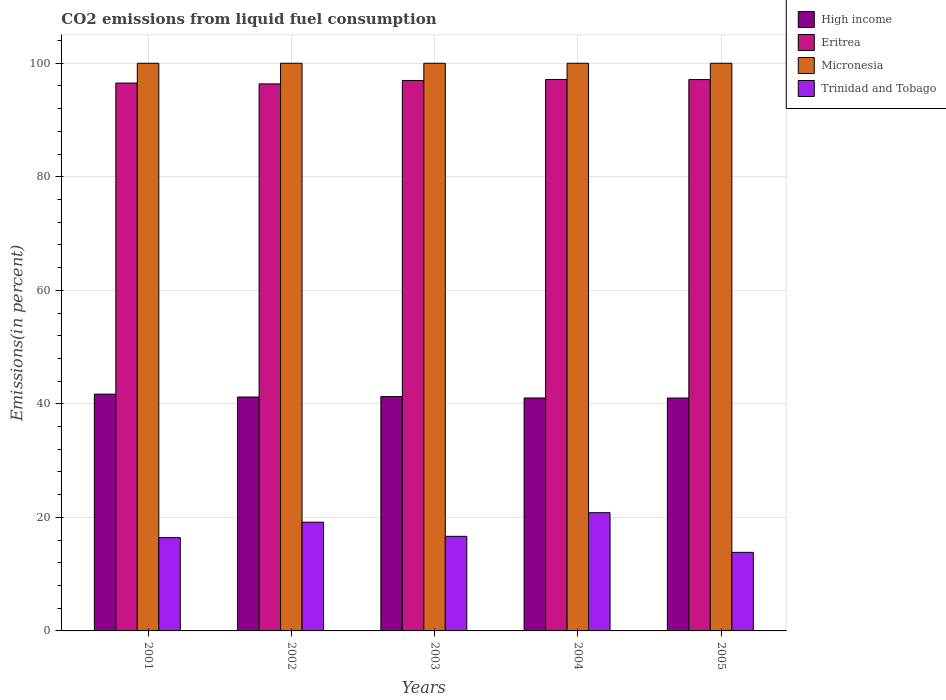How many different coloured bars are there?
Provide a succinct answer. 4. Are the number of bars on each tick of the X-axis equal?
Your answer should be very brief. Yes. How many bars are there on the 3rd tick from the left?
Keep it short and to the point. 4. How many bars are there on the 2nd tick from the right?
Your response must be concise. 4. In how many cases, is the number of bars for a given year not equal to the number of legend labels?
Your answer should be compact. 0. What is the total CO2 emitted in High income in 2001?
Provide a succinct answer. 41.71. Across all years, what is the maximum total CO2 emitted in Eritrea?
Offer a very short reply. 97.14. In which year was the total CO2 emitted in High income minimum?
Provide a short and direct response. 2005. What is the total total CO2 emitted in High income in the graph?
Your answer should be compact. 206.25. What is the difference between the total CO2 emitted in Micronesia in 2001 and that in 2004?
Make the answer very short. 0. What is the difference between the total CO2 emitted in High income in 2003 and the total CO2 emitted in Trinidad and Tobago in 2005?
Your response must be concise. 27.44. What is the average total CO2 emitted in Trinidad and Tobago per year?
Keep it short and to the point. 17.38. In the year 2001, what is the difference between the total CO2 emitted in Eritrea and total CO2 emitted in High income?
Offer a terse response. 54.8. In how many years, is the total CO2 emitted in Trinidad and Tobago greater than 16 %?
Keep it short and to the point. 4. What is the ratio of the total CO2 emitted in Trinidad and Tobago in 2001 to that in 2003?
Make the answer very short. 0.99. Is the total CO2 emitted in Micronesia in 2003 less than that in 2004?
Your response must be concise. No. What is the difference between the highest and the second highest total CO2 emitted in Trinidad and Tobago?
Offer a very short reply. 1.67. What is the difference between the highest and the lowest total CO2 emitted in Eritrea?
Offer a terse response. 0.78. In how many years, is the total CO2 emitted in High income greater than the average total CO2 emitted in High income taken over all years?
Provide a succinct answer. 2. Is the sum of the total CO2 emitted in High income in 2001 and 2002 greater than the maximum total CO2 emitted in Eritrea across all years?
Offer a terse response. No. Is it the case that in every year, the sum of the total CO2 emitted in Trinidad and Tobago and total CO2 emitted in Eritrea is greater than the sum of total CO2 emitted in Micronesia and total CO2 emitted in High income?
Your answer should be very brief. Yes. What does the 2nd bar from the left in 2001 represents?
Offer a terse response. Eritrea. What does the 3rd bar from the right in 2005 represents?
Offer a very short reply. Eritrea. Is it the case that in every year, the sum of the total CO2 emitted in High income and total CO2 emitted in Micronesia is greater than the total CO2 emitted in Eritrea?
Provide a short and direct response. Yes. How many bars are there?
Keep it short and to the point. 20. Are all the bars in the graph horizontal?
Provide a succinct answer. No. What is the difference between two consecutive major ticks on the Y-axis?
Your answer should be compact. 20. Are the values on the major ticks of Y-axis written in scientific E-notation?
Keep it short and to the point. No. Does the graph contain any zero values?
Give a very brief answer. No. Does the graph contain grids?
Provide a short and direct response. Yes. Where does the legend appear in the graph?
Make the answer very short. Top right. How are the legend labels stacked?
Your answer should be very brief. Vertical. What is the title of the graph?
Ensure brevity in your answer.  CO2 emissions from liquid fuel consumption. Does "Djibouti" appear as one of the legend labels in the graph?
Provide a short and direct response. No. What is the label or title of the Y-axis?
Keep it short and to the point. Emissions(in percent). What is the Emissions(in percent) of High income in 2001?
Your answer should be compact. 41.71. What is the Emissions(in percent) of Eritrea in 2001?
Ensure brevity in your answer.  96.51. What is the Emissions(in percent) in Micronesia in 2001?
Provide a short and direct response. 100. What is the Emissions(in percent) in Trinidad and Tobago in 2001?
Provide a short and direct response. 16.44. What is the Emissions(in percent) of High income in 2002?
Give a very brief answer. 41.2. What is the Emissions(in percent) of Eritrea in 2002?
Make the answer very short. 96.36. What is the Emissions(in percent) in Micronesia in 2002?
Ensure brevity in your answer.  100. What is the Emissions(in percent) in Trinidad and Tobago in 2002?
Your response must be concise. 19.15. What is the Emissions(in percent) of High income in 2003?
Your response must be concise. 41.28. What is the Emissions(in percent) of Eritrea in 2003?
Your response must be concise. 96.97. What is the Emissions(in percent) in Micronesia in 2003?
Provide a short and direct response. 100. What is the Emissions(in percent) of Trinidad and Tobago in 2003?
Ensure brevity in your answer.  16.66. What is the Emissions(in percent) in High income in 2004?
Offer a terse response. 41.03. What is the Emissions(in percent) of Eritrea in 2004?
Provide a succinct answer. 97.14. What is the Emissions(in percent) of Trinidad and Tobago in 2004?
Your response must be concise. 20.83. What is the Emissions(in percent) of High income in 2005?
Your answer should be compact. 41.02. What is the Emissions(in percent) in Eritrea in 2005?
Offer a terse response. 97.13. What is the Emissions(in percent) of Micronesia in 2005?
Your answer should be very brief. 100. What is the Emissions(in percent) of Trinidad and Tobago in 2005?
Offer a very short reply. 13.84. Across all years, what is the maximum Emissions(in percent) of High income?
Keep it short and to the point. 41.71. Across all years, what is the maximum Emissions(in percent) in Eritrea?
Make the answer very short. 97.14. Across all years, what is the maximum Emissions(in percent) in Micronesia?
Make the answer very short. 100. Across all years, what is the maximum Emissions(in percent) in Trinidad and Tobago?
Provide a succinct answer. 20.83. Across all years, what is the minimum Emissions(in percent) of High income?
Your answer should be compact. 41.02. Across all years, what is the minimum Emissions(in percent) of Eritrea?
Make the answer very short. 96.36. Across all years, what is the minimum Emissions(in percent) in Micronesia?
Offer a terse response. 100. Across all years, what is the minimum Emissions(in percent) of Trinidad and Tobago?
Your answer should be very brief. 13.84. What is the total Emissions(in percent) in High income in the graph?
Your answer should be compact. 206.25. What is the total Emissions(in percent) in Eritrea in the graph?
Your response must be concise. 484.12. What is the total Emissions(in percent) of Trinidad and Tobago in the graph?
Give a very brief answer. 86.92. What is the difference between the Emissions(in percent) in High income in 2001 and that in 2002?
Give a very brief answer. 0.51. What is the difference between the Emissions(in percent) of Eritrea in 2001 and that in 2002?
Ensure brevity in your answer.  0.15. What is the difference between the Emissions(in percent) in Micronesia in 2001 and that in 2002?
Offer a very short reply. 0. What is the difference between the Emissions(in percent) in Trinidad and Tobago in 2001 and that in 2002?
Give a very brief answer. -2.72. What is the difference between the Emissions(in percent) in High income in 2001 and that in 2003?
Your response must be concise. 0.43. What is the difference between the Emissions(in percent) of Eritrea in 2001 and that in 2003?
Make the answer very short. -0.46. What is the difference between the Emissions(in percent) of Trinidad and Tobago in 2001 and that in 2003?
Your answer should be very brief. -0.23. What is the difference between the Emissions(in percent) of High income in 2001 and that in 2004?
Your answer should be compact. 0.68. What is the difference between the Emissions(in percent) of Eritrea in 2001 and that in 2004?
Your answer should be very brief. -0.63. What is the difference between the Emissions(in percent) of Micronesia in 2001 and that in 2004?
Your response must be concise. 0. What is the difference between the Emissions(in percent) of Trinidad and Tobago in 2001 and that in 2004?
Ensure brevity in your answer.  -4.39. What is the difference between the Emissions(in percent) in High income in 2001 and that in 2005?
Give a very brief answer. 0.69. What is the difference between the Emissions(in percent) in Eritrea in 2001 and that in 2005?
Ensure brevity in your answer.  -0.62. What is the difference between the Emissions(in percent) in Trinidad and Tobago in 2001 and that in 2005?
Ensure brevity in your answer.  2.59. What is the difference between the Emissions(in percent) in High income in 2002 and that in 2003?
Keep it short and to the point. -0.07. What is the difference between the Emissions(in percent) in Eritrea in 2002 and that in 2003?
Your answer should be very brief. -0.61. What is the difference between the Emissions(in percent) of Trinidad and Tobago in 2002 and that in 2003?
Ensure brevity in your answer.  2.49. What is the difference between the Emissions(in percent) of High income in 2002 and that in 2004?
Make the answer very short. 0.17. What is the difference between the Emissions(in percent) in Eritrea in 2002 and that in 2004?
Your answer should be very brief. -0.78. What is the difference between the Emissions(in percent) of Trinidad and Tobago in 2002 and that in 2004?
Give a very brief answer. -1.67. What is the difference between the Emissions(in percent) in High income in 2002 and that in 2005?
Your answer should be very brief. 0.18. What is the difference between the Emissions(in percent) in Eritrea in 2002 and that in 2005?
Make the answer very short. -0.77. What is the difference between the Emissions(in percent) in Micronesia in 2002 and that in 2005?
Your response must be concise. 0. What is the difference between the Emissions(in percent) of Trinidad and Tobago in 2002 and that in 2005?
Keep it short and to the point. 5.31. What is the difference between the Emissions(in percent) of High income in 2003 and that in 2004?
Ensure brevity in your answer.  0.25. What is the difference between the Emissions(in percent) in Eritrea in 2003 and that in 2004?
Offer a terse response. -0.17. What is the difference between the Emissions(in percent) of Micronesia in 2003 and that in 2004?
Provide a succinct answer. 0. What is the difference between the Emissions(in percent) of Trinidad and Tobago in 2003 and that in 2004?
Provide a short and direct response. -4.16. What is the difference between the Emissions(in percent) of High income in 2003 and that in 2005?
Provide a short and direct response. 0.26. What is the difference between the Emissions(in percent) of Eritrea in 2003 and that in 2005?
Make the answer very short. -0.16. What is the difference between the Emissions(in percent) of Trinidad and Tobago in 2003 and that in 2005?
Your answer should be very brief. 2.82. What is the difference between the Emissions(in percent) of High income in 2004 and that in 2005?
Offer a terse response. 0.01. What is the difference between the Emissions(in percent) in Eritrea in 2004 and that in 2005?
Your answer should be very brief. 0.01. What is the difference between the Emissions(in percent) in Trinidad and Tobago in 2004 and that in 2005?
Your response must be concise. 6.98. What is the difference between the Emissions(in percent) in High income in 2001 and the Emissions(in percent) in Eritrea in 2002?
Provide a short and direct response. -54.65. What is the difference between the Emissions(in percent) of High income in 2001 and the Emissions(in percent) of Micronesia in 2002?
Your answer should be very brief. -58.29. What is the difference between the Emissions(in percent) of High income in 2001 and the Emissions(in percent) of Trinidad and Tobago in 2002?
Offer a very short reply. 22.56. What is the difference between the Emissions(in percent) in Eritrea in 2001 and the Emissions(in percent) in Micronesia in 2002?
Provide a succinct answer. -3.49. What is the difference between the Emissions(in percent) in Eritrea in 2001 and the Emissions(in percent) in Trinidad and Tobago in 2002?
Your answer should be compact. 77.36. What is the difference between the Emissions(in percent) in Micronesia in 2001 and the Emissions(in percent) in Trinidad and Tobago in 2002?
Provide a short and direct response. 80.85. What is the difference between the Emissions(in percent) of High income in 2001 and the Emissions(in percent) of Eritrea in 2003?
Give a very brief answer. -55.26. What is the difference between the Emissions(in percent) in High income in 2001 and the Emissions(in percent) in Micronesia in 2003?
Offer a terse response. -58.29. What is the difference between the Emissions(in percent) in High income in 2001 and the Emissions(in percent) in Trinidad and Tobago in 2003?
Ensure brevity in your answer.  25.05. What is the difference between the Emissions(in percent) in Eritrea in 2001 and the Emissions(in percent) in Micronesia in 2003?
Your answer should be very brief. -3.49. What is the difference between the Emissions(in percent) in Eritrea in 2001 and the Emissions(in percent) in Trinidad and Tobago in 2003?
Offer a very short reply. 79.85. What is the difference between the Emissions(in percent) in Micronesia in 2001 and the Emissions(in percent) in Trinidad and Tobago in 2003?
Offer a terse response. 83.34. What is the difference between the Emissions(in percent) in High income in 2001 and the Emissions(in percent) in Eritrea in 2004?
Your response must be concise. -55.43. What is the difference between the Emissions(in percent) of High income in 2001 and the Emissions(in percent) of Micronesia in 2004?
Your answer should be compact. -58.29. What is the difference between the Emissions(in percent) in High income in 2001 and the Emissions(in percent) in Trinidad and Tobago in 2004?
Ensure brevity in your answer.  20.88. What is the difference between the Emissions(in percent) in Eritrea in 2001 and the Emissions(in percent) in Micronesia in 2004?
Your answer should be compact. -3.49. What is the difference between the Emissions(in percent) of Eritrea in 2001 and the Emissions(in percent) of Trinidad and Tobago in 2004?
Provide a short and direct response. 75.69. What is the difference between the Emissions(in percent) of Micronesia in 2001 and the Emissions(in percent) of Trinidad and Tobago in 2004?
Provide a short and direct response. 79.17. What is the difference between the Emissions(in percent) in High income in 2001 and the Emissions(in percent) in Eritrea in 2005?
Make the answer very short. -55.42. What is the difference between the Emissions(in percent) of High income in 2001 and the Emissions(in percent) of Micronesia in 2005?
Your answer should be very brief. -58.29. What is the difference between the Emissions(in percent) in High income in 2001 and the Emissions(in percent) in Trinidad and Tobago in 2005?
Your answer should be compact. 27.87. What is the difference between the Emissions(in percent) of Eritrea in 2001 and the Emissions(in percent) of Micronesia in 2005?
Your response must be concise. -3.49. What is the difference between the Emissions(in percent) of Eritrea in 2001 and the Emissions(in percent) of Trinidad and Tobago in 2005?
Offer a terse response. 82.67. What is the difference between the Emissions(in percent) in Micronesia in 2001 and the Emissions(in percent) in Trinidad and Tobago in 2005?
Ensure brevity in your answer.  86.16. What is the difference between the Emissions(in percent) in High income in 2002 and the Emissions(in percent) in Eritrea in 2003?
Your response must be concise. -55.76. What is the difference between the Emissions(in percent) in High income in 2002 and the Emissions(in percent) in Micronesia in 2003?
Your answer should be very brief. -58.8. What is the difference between the Emissions(in percent) of High income in 2002 and the Emissions(in percent) of Trinidad and Tobago in 2003?
Your response must be concise. 24.54. What is the difference between the Emissions(in percent) in Eritrea in 2002 and the Emissions(in percent) in Micronesia in 2003?
Offer a very short reply. -3.64. What is the difference between the Emissions(in percent) in Eritrea in 2002 and the Emissions(in percent) in Trinidad and Tobago in 2003?
Ensure brevity in your answer.  79.7. What is the difference between the Emissions(in percent) in Micronesia in 2002 and the Emissions(in percent) in Trinidad and Tobago in 2003?
Your answer should be very brief. 83.34. What is the difference between the Emissions(in percent) of High income in 2002 and the Emissions(in percent) of Eritrea in 2004?
Offer a terse response. -55.94. What is the difference between the Emissions(in percent) in High income in 2002 and the Emissions(in percent) in Micronesia in 2004?
Ensure brevity in your answer.  -58.8. What is the difference between the Emissions(in percent) in High income in 2002 and the Emissions(in percent) in Trinidad and Tobago in 2004?
Ensure brevity in your answer.  20.38. What is the difference between the Emissions(in percent) in Eritrea in 2002 and the Emissions(in percent) in Micronesia in 2004?
Offer a terse response. -3.64. What is the difference between the Emissions(in percent) of Eritrea in 2002 and the Emissions(in percent) of Trinidad and Tobago in 2004?
Give a very brief answer. 75.54. What is the difference between the Emissions(in percent) in Micronesia in 2002 and the Emissions(in percent) in Trinidad and Tobago in 2004?
Your answer should be compact. 79.17. What is the difference between the Emissions(in percent) of High income in 2002 and the Emissions(in percent) of Eritrea in 2005?
Make the answer very short. -55.92. What is the difference between the Emissions(in percent) in High income in 2002 and the Emissions(in percent) in Micronesia in 2005?
Make the answer very short. -58.8. What is the difference between the Emissions(in percent) in High income in 2002 and the Emissions(in percent) in Trinidad and Tobago in 2005?
Keep it short and to the point. 27.36. What is the difference between the Emissions(in percent) of Eritrea in 2002 and the Emissions(in percent) of Micronesia in 2005?
Keep it short and to the point. -3.64. What is the difference between the Emissions(in percent) in Eritrea in 2002 and the Emissions(in percent) in Trinidad and Tobago in 2005?
Your response must be concise. 82.52. What is the difference between the Emissions(in percent) of Micronesia in 2002 and the Emissions(in percent) of Trinidad and Tobago in 2005?
Offer a terse response. 86.16. What is the difference between the Emissions(in percent) in High income in 2003 and the Emissions(in percent) in Eritrea in 2004?
Make the answer very short. -55.86. What is the difference between the Emissions(in percent) of High income in 2003 and the Emissions(in percent) of Micronesia in 2004?
Ensure brevity in your answer.  -58.72. What is the difference between the Emissions(in percent) in High income in 2003 and the Emissions(in percent) in Trinidad and Tobago in 2004?
Ensure brevity in your answer.  20.45. What is the difference between the Emissions(in percent) in Eritrea in 2003 and the Emissions(in percent) in Micronesia in 2004?
Offer a terse response. -3.03. What is the difference between the Emissions(in percent) in Eritrea in 2003 and the Emissions(in percent) in Trinidad and Tobago in 2004?
Keep it short and to the point. 76.14. What is the difference between the Emissions(in percent) in Micronesia in 2003 and the Emissions(in percent) in Trinidad and Tobago in 2004?
Ensure brevity in your answer.  79.17. What is the difference between the Emissions(in percent) in High income in 2003 and the Emissions(in percent) in Eritrea in 2005?
Ensure brevity in your answer.  -55.85. What is the difference between the Emissions(in percent) in High income in 2003 and the Emissions(in percent) in Micronesia in 2005?
Your response must be concise. -58.72. What is the difference between the Emissions(in percent) of High income in 2003 and the Emissions(in percent) of Trinidad and Tobago in 2005?
Provide a succinct answer. 27.44. What is the difference between the Emissions(in percent) of Eritrea in 2003 and the Emissions(in percent) of Micronesia in 2005?
Your answer should be very brief. -3.03. What is the difference between the Emissions(in percent) in Eritrea in 2003 and the Emissions(in percent) in Trinidad and Tobago in 2005?
Offer a very short reply. 83.13. What is the difference between the Emissions(in percent) of Micronesia in 2003 and the Emissions(in percent) of Trinidad and Tobago in 2005?
Offer a very short reply. 86.16. What is the difference between the Emissions(in percent) in High income in 2004 and the Emissions(in percent) in Eritrea in 2005?
Provide a short and direct response. -56.1. What is the difference between the Emissions(in percent) of High income in 2004 and the Emissions(in percent) of Micronesia in 2005?
Your response must be concise. -58.97. What is the difference between the Emissions(in percent) in High income in 2004 and the Emissions(in percent) in Trinidad and Tobago in 2005?
Your response must be concise. 27.19. What is the difference between the Emissions(in percent) of Eritrea in 2004 and the Emissions(in percent) of Micronesia in 2005?
Provide a succinct answer. -2.86. What is the difference between the Emissions(in percent) of Eritrea in 2004 and the Emissions(in percent) of Trinidad and Tobago in 2005?
Provide a succinct answer. 83.3. What is the difference between the Emissions(in percent) of Micronesia in 2004 and the Emissions(in percent) of Trinidad and Tobago in 2005?
Keep it short and to the point. 86.16. What is the average Emissions(in percent) of High income per year?
Ensure brevity in your answer.  41.25. What is the average Emissions(in percent) of Eritrea per year?
Keep it short and to the point. 96.82. What is the average Emissions(in percent) of Micronesia per year?
Offer a very short reply. 100. What is the average Emissions(in percent) of Trinidad and Tobago per year?
Ensure brevity in your answer.  17.38. In the year 2001, what is the difference between the Emissions(in percent) of High income and Emissions(in percent) of Eritrea?
Your answer should be very brief. -54.8. In the year 2001, what is the difference between the Emissions(in percent) of High income and Emissions(in percent) of Micronesia?
Offer a very short reply. -58.29. In the year 2001, what is the difference between the Emissions(in percent) in High income and Emissions(in percent) in Trinidad and Tobago?
Offer a very short reply. 25.27. In the year 2001, what is the difference between the Emissions(in percent) of Eritrea and Emissions(in percent) of Micronesia?
Provide a short and direct response. -3.49. In the year 2001, what is the difference between the Emissions(in percent) of Eritrea and Emissions(in percent) of Trinidad and Tobago?
Offer a terse response. 80.08. In the year 2001, what is the difference between the Emissions(in percent) in Micronesia and Emissions(in percent) in Trinidad and Tobago?
Give a very brief answer. 83.56. In the year 2002, what is the difference between the Emissions(in percent) in High income and Emissions(in percent) in Eritrea?
Your answer should be very brief. -55.16. In the year 2002, what is the difference between the Emissions(in percent) of High income and Emissions(in percent) of Micronesia?
Give a very brief answer. -58.8. In the year 2002, what is the difference between the Emissions(in percent) in High income and Emissions(in percent) in Trinidad and Tobago?
Offer a very short reply. 22.05. In the year 2002, what is the difference between the Emissions(in percent) in Eritrea and Emissions(in percent) in Micronesia?
Ensure brevity in your answer.  -3.64. In the year 2002, what is the difference between the Emissions(in percent) of Eritrea and Emissions(in percent) of Trinidad and Tobago?
Your response must be concise. 77.21. In the year 2002, what is the difference between the Emissions(in percent) in Micronesia and Emissions(in percent) in Trinidad and Tobago?
Offer a terse response. 80.85. In the year 2003, what is the difference between the Emissions(in percent) of High income and Emissions(in percent) of Eritrea?
Offer a very short reply. -55.69. In the year 2003, what is the difference between the Emissions(in percent) of High income and Emissions(in percent) of Micronesia?
Offer a terse response. -58.72. In the year 2003, what is the difference between the Emissions(in percent) of High income and Emissions(in percent) of Trinidad and Tobago?
Ensure brevity in your answer.  24.62. In the year 2003, what is the difference between the Emissions(in percent) in Eritrea and Emissions(in percent) in Micronesia?
Give a very brief answer. -3.03. In the year 2003, what is the difference between the Emissions(in percent) in Eritrea and Emissions(in percent) in Trinidad and Tobago?
Provide a succinct answer. 80.31. In the year 2003, what is the difference between the Emissions(in percent) of Micronesia and Emissions(in percent) of Trinidad and Tobago?
Ensure brevity in your answer.  83.34. In the year 2004, what is the difference between the Emissions(in percent) in High income and Emissions(in percent) in Eritrea?
Your response must be concise. -56.11. In the year 2004, what is the difference between the Emissions(in percent) of High income and Emissions(in percent) of Micronesia?
Make the answer very short. -58.97. In the year 2004, what is the difference between the Emissions(in percent) in High income and Emissions(in percent) in Trinidad and Tobago?
Offer a very short reply. 20.21. In the year 2004, what is the difference between the Emissions(in percent) in Eritrea and Emissions(in percent) in Micronesia?
Offer a terse response. -2.86. In the year 2004, what is the difference between the Emissions(in percent) in Eritrea and Emissions(in percent) in Trinidad and Tobago?
Your answer should be very brief. 76.32. In the year 2004, what is the difference between the Emissions(in percent) of Micronesia and Emissions(in percent) of Trinidad and Tobago?
Your answer should be very brief. 79.17. In the year 2005, what is the difference between the Emissions(in percent) in High income and Emissions(in percent) in Eritrea?
Offer a very short reply. -56.11. In the year 2005, what is the difference between the Emissions(in percent) of High income and Emissions(in percent) of Micronesia?
Your response must be concise. -58.98. In the year 2005, what is the difference between the Emissions(in percent) of High income and Emissions(in percent) of Trinidad and Tobago?
Offer a terse response. 27.18. In the year 2005, what is the difference between the Emissions(in percent) of Eritrea and Emissions(in percent) of Micronesia?
Make the answer very short. -2.87. In the year 2005, what is the difference between the Emissions(in percent) in Eritrea and Emissions(in percent) in Trinidad and Tobago?
Offer a very short reply. 83.29. In the year 2005, what is the difference between the Emissions(in percent) of Micronesia and Emissions(in percent) of Trinidad and Tobago?
Offer a very short reply. 86.16. What is the ratio of the Emissions(in percent) in High income in 2001 to that in 2002?
Provide a short and direct response. 1.01. What is the ratio of the Emissions(in percent) of Eritrea in 2001 to that in 2002?
Keep it short and to the point. 1. What is the ratio of the Emissions(in percent) of Trinidad and Tobago in 2001 to that in 2002?
Your answer should be very brief. 0.86. What is the ratio of the Emissions(in percent) of High income in 2001 to that in 2003?
Your answer should be compact. 1.01. What is the ratio of the Emissions(in percent) in Eritrea in 2001 to that in 2003?
Keep it short and to the point. 1. What is the ratio of the Emissions(in percent) of Micronesia in 2001 to that in 2003?
Your answer should be compact. 1. What is the ratio of the Emissions(in percent) of Trinidad and Tobago in 2001 to that in 2003?
Give a very brief answer. 0.99. What is the ratio of the Emissions(in percent) of High income in 2001 to that in 2004?
Keep it short and to the point. 1.02. What is the ratio of the Emissions(in percent) of Micronesia in 2001 to that in 2004?
Your answer should be very brief. 1. What is the ratio of the Emissions(in percent) in Trinidad and Tobago in 2001 to that in 2004?
Your response must be concise. 0.79. What is the ratio of the Emissions(in percent) in High income in 2001 to that in 2005?
Your response must be concise. 1.02. What is the ratio of the Emissions(in percent) in Trinidad and Tobago in 2001 to that in 2005?
Offer a very short reply. 1.19. What is the ratio of the Emissions(in percent) in Eritrea in 2002 to that in 2003?
Make the answer very short. 0.99. What is the ratio of the Emissions(in percent) of Micronesia in 2002 to that in 2003?
Your answer should be very brief. 1. What is the ratio of the Emissions(in percent) of Trinidad and Tobago in 2002 to that in 2003?
Offer a very short reply. 1.15. What is the ratio of the Emissions(in percent) in Micronesia in 2002 to that in 2004?
Offer a terse response. 1. What is the ratio of the Emissions(in percent) in Trinidad and Tobago in 2002 to that in 2004?
Make the answer very short. 0.92. What is the ratio of the Emissions(in percent) of Micronesia in 2002 to that in 2005?
Keep it short and to the point. 1. What is the ratio of the Emissions(in percent) in Trinidad and Tobago in 2002 to that in 2005?
Make the answer very short. 1.38. What is the ratio of the Emissions(in percent) of Eritrea in 2003 to that in 2004?
Give a very brief answer. 1. What is the ratio of the Emissions(in percent) of Trinidad and Tobago in 2003 to that in 2004?
Your answer should be very brief. 0.8. What is the ratio of the Emissions(in percent) of High income in 2003 to that in 2005?
Keep it short and to the point. 1.01. What is the ratio of the Emissions(in percent) of Eritrea in 2003 to that in 2005?
Offer a very short reply. 1. What is the ratio of the Emissions(in percent) in Micronesia in 2003 to that in 2005?
Make the answer very short. 1. What is the ratio of the Emissions(in percent) in Trinidad and Tobago in 2003 to that in 2005?
Keep it short and to the point. 1.2. What is the ratio of the Emissions(in percent) in Eritrea in 2004 to that in 2005?
Your response must be concise. 1. What is the ratio of the Emissions(in percent) of Trinidad and Tobago in 2004 to that in 2005?
Offer a terse response. 1.5. What is the difference between the highest and the second highest Emissions(in percent) in High income?
Offer a terse response. 0.43. What is the difference between the highest and the second highest Emissions(in percent) of Eritrea?
Provide a succinct answer. 0.01. What is the difference between the highest and the second highest Emissions(in percent) in Micronesia?
Your answer should be very brief. 0. What is the difference between the highest and the second highest Emissions(in percent) in Trinidad and Tobago?
Provide a short and direct response. 1.67. What is the difference between the highest and the lowest Emissions(in percent) in High income?
Offer a terse response. 0.69. What is the difference between the highest and the lowest Emissions(in percent) of Eritrea?
Your response must be concise. 0.78. What is the difference between the highest and the lowest Emissions(in percent) in Trinidad and Tobago?
Your answer should be compact. 6.98. 